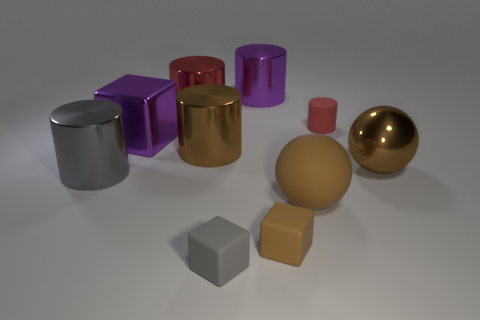Subtract all gray metal cylinders. How many cylinders are left? 4 Subtract 2 cylinders. How many cylinders are left? 3 Subtract all brown balls. How many red cylinders are left? 2 Subtract all brown cylinders. How many cylinders are left? 4 Subtract all cubes. How many objects are left? 7 Subtract all red cylinders. Subtract all yellow balls. How many cylinders are left? 3 Subtract 0 yellow cylinders. How many objects are left? 10 Subtract all large brown rubber things. Subtract all red rubber blocks. How many objects are left? 9 Add 2 brown cubes. How many brown cubes are left? 3 Add 3 large metal cubes. How many large metal cubes exist? 4 